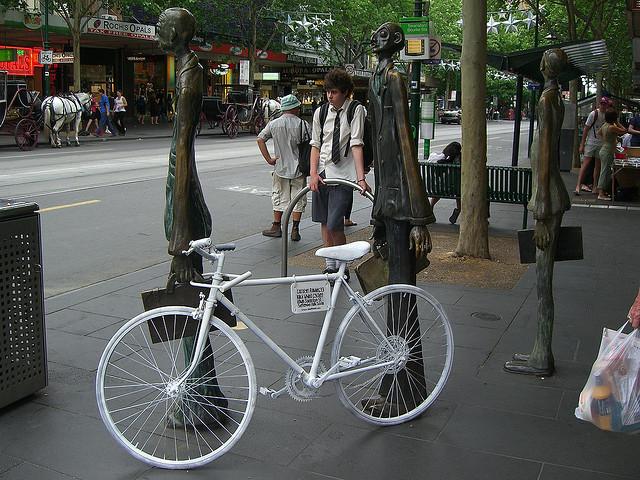What is the bike for?
Concise answer only. Decoration. How many statues of people are there?
Write a very short answer. 3. Are most bike wheels the color of this one?
Write a very short answer. No. IS there melons in the picture?
Short answer required. No. 